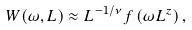<formula> <loc_0><loc_0><loc_500><loc_500>W ( \omega , L ) \approx L ^ { - 1 / \nu } f \left ( \omega L ^ { z } \right ) ,</formula> 